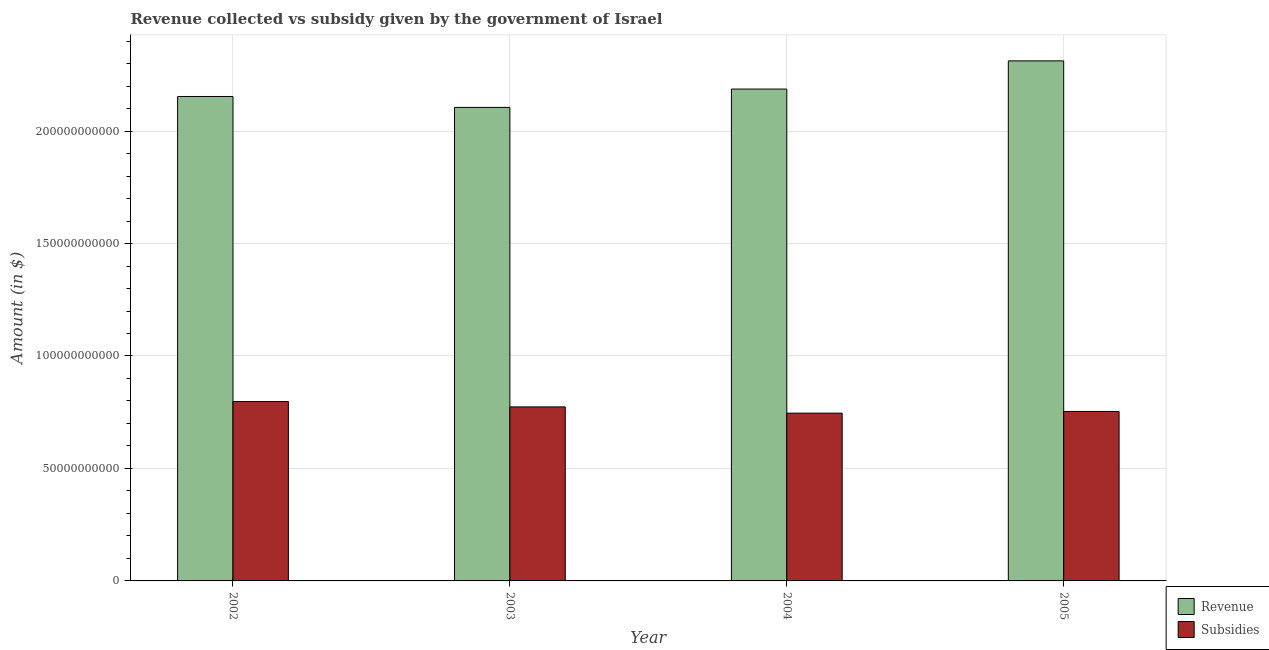How many groups of bars are there?
Offer a terse response. 4. Are the number of bars per tick equal to the number of legend labels?
Your response must be concise. Yes. How many bars are there on the 4th tick from the left?
Your answer should be compact. 2. What is the amount of subsidies given in 2003?
Keep it short and to the point. 7.74e+1. Across all years, what is the maximum amount of subsidies given?
Offer a very short reply. 7.98e+1. Across all years, what is the minimum amount of revenue collected?
Ensure brevity in your answer.  2.11e+11. In which year was the amount of revenue collected minimum?
Your response must be concise. 2003. What is the total amount of revenue collected in the graph?
Your answer should be compact. 8.76e+11. What is the difference between the amount of revenue collected in 2004 and that in 2005?
Your response must be concise. -1.25e+1. What is the difference between the amount of revenue collected in 2004 and the amount of subsidies given in 2003?
Your answer should be very brief. 8.16e+09. What is the average amount of subsidies given per year?
Make the answer very short. 7.68e+1. In the year 2003, what is the difference between the amount of subsidies given and amount of revenue collected?
Provide a succinct answer. 0. In how many years, is the amount of revenue collected greater than 60000000000 $?
Provide a succinct answer. 4. What is the ratio of the amount of subsidies given in 2003 to that in 2005?
Give a very brief answer. 1.03. Is the amount of revenue collected in 2003 less than that in 2005?
Offer a very short reply. Yes. What is the difference between the highest and the second highest amount of subsidies given?
Provide a succinct answer. 2.40e+09. What is the difference between the highest and the lowest amount of revenue collected?
Offer a very short reply. 2.07e+1. In how many years, is the amount of revenue collected greater than the average amount of revenue collected taken over all years?
Offer a very short reply. 1. What does the 2nd bar from the left in 2004 represents?
Give a very brief answer. Subsidies. What does the 2nd bar from the right in 2002 represents?
Your response must be concise. Revenue. How many bars are there?
Ensure brevity in your answer.  8. What is the difference between two consecutive major ticks on the Y-axis?
Your response must be concise. 5.00e+1. Does the graph contain grids?
Provide a short and direct response. Yes. How many legend labels are there?
Offer a very short reply. 2. What is the title of the graph?
Make the answer very short. Revenue collected vs subsidy given by the government of Israel. What is the label or title of the X-axis?
Make the answer very short. Year. What is the label or title of the Y-axis?
Your response must be concise. Amount (in $). What is the Amount (in $) of Revenue in 2002?
Provide a succinct answer. 2.15e+11. What is the Amount (in $) in Subsidies in 2002?
Make the answer very short. 7.98e+1. What is the Amount (in $) in Revenue in 2003?
Your answer should be very brief. 2.11e+11. What is the Amount (in $) in Subsidies in 2003?
Ensure brevity in your answer.  7.74e+1. What is the Amount (in $) in Revenue in 2004?
Give a very brief answer. 2.19e+11. What is the Amount (in $) in Subsidies in 2004?
Ensure brevity in your answer.  7.46e+1. What is the Amount (in $) in Revenue in 2005?
Offer a very short reply. 2.31e+11. What is the Amount (in $) of Subsidies in 2005?
Give a very brief answer. 7.53e+1. Across all years, what is the maximum Amount (in $) in Revenue?
Keep it short and to the point. 2.31e+11. Across all years, what is the maximum Amount (in $) in Subsidies?
Your response must be concise. 7.98e+1. Across all years, what is the minimum Amount (in $) of Revenue?
Make the answer very short. 2.11e+11. Across all years, what is the minimum Amount (in $) in Subsidies?
Provide a succinct answer. 7.46e+1. What is the total Amount (in $) of Revenue in the graph?
Offer a terse response. 8.76e+11. What is the total Amount (in $) of Subsidies in the graph?
Keep it short and to the point. 3.07e+11. What is the difference between the Amount (in $) in Revenue in 2002 and that in 2003?
Make the answer very short. 4.85e+09. What is the difference between the Amount (in $) in Subsidies in 2002 and that in 2003?
Offer a very short reply. 2.40e+09. What is the difference between the Amount (in $) of Revenue in 2002 and that in 2004?
Give a very brief answer. -3.30e+09. What is the difference between the Amount (in $) in Subsidies in 2002 and that in 2004?
Your answer should be compact. 5.18e+09. What is the difference between the Amount (in $) of Revenue in 2002 and that in 2005?
Ensure brevity in your answer.  -1.58e+1. What is the difference between the Amount (in $) in Subsidies in 2002 and that in 2005?
Keep it short and to the point. 4.43e+09. What is the difference between the Amount (in $) in Revenue in 2003 and that in 2004?
Make the answer very short. -8.16e+09. What is the difference between the Amount (in $) in Subsidies in 2003 and that in 2004?
Your response must be concise. 2.78e+09. What is the difference between the Amount (in $) in Revenue in 2003 and that in 2005?
Keep it short and to the point. -2.07e+1. What is the difference between the Amount (in $) in Subsidies in 2003 and that in 2005?
Give a very brief answer. 2.03e+09. What is the difference between the Amount (in $) in Revenue in 2004 and that in 2005?
Your response must be concise. -1.25e+1. What is the difference between the Amount (in $) of Subsidies in 2004 and that in 2005?
Provide a short and direct response. -7.47e+08. What is the difference between the Amount (in $) of Revenue in 2002 and the Amount (in $) of Subsidies in 2003?
Your response must be concise. 1.38e+11. What is the difference between the Amount (in $) of Revenue in 2002 and the Amount (in $) of Subsidies in 2004?
Your response must be concise. 1.41e+11. What is the difference between the Amount (in $) of Revenue in 2002 and the Amount (in $) of Subsidies in 2005?
Give a very brief answer. 1.40e+11. What is the difference between the Amount (in $) of Revenue in 2003 and the Amount (in $) of Subsidies in 2004?
Your answer should be compact. 1.36e+11. What is the difference between the Amount (in $) of Revenue in 2003 and the Amount (in $) of Subsidies in 2005?
Keep it short and to the point. 1.35e+11. What is the difference between the Amount (in $) of Revenue in 2004 and the Amount (in $) of Subsidies in 2005?
Keep it short and to the point. 1.43e+11. What is the average Amount (in $) of Revenue per year?
Offer a very short reply. 2.19e+11. What is the average Amount (in $) in Subsidies per year?
Offer a terse response. 7.68e+1. In the year 2002, what is the difference between the Amount (in $) of Revenue and Amount (in $) of Subsidies?
Provide a succinct answer. 1.36e+11. In the year 2003, what is the difference between the Amount (in $) of Revenue and Amount (in $) of Subsidies?
Ensure brevity in your answer.  1.33e+11. In the year 2004, what is the difference between the Amount (in $) of Revenue and Amount (in $) of Subsidies?
Make the answer very short. 1.44e+11. In the year 2005, what is the difference between the Amount (in $) of Revenue and Amount (in $) of Subsidies?
Offer a terse response. 1.56e+11. What is the ratio of the Amount (in $) in Revenue in 2002 to that in 2003?
Give a very brief answer. 1.02. What is the ratio of the Amount (in $) of Subsidies in 2002 to that in 2003?
Offer a terse response. 1.03. What is the ratio of the Amount (in $) in Revenue in 2002 to that in 2004?
Offer a terse response. 0.98. What is the ratio of the Amount (in $) in Subsidies in 2002 to that in 2004?
Offer a terse response. 1.07. What is the ratio of the Amount (in $) of Revenue in 2002 to that in 2005?
Your answer should be compact. 0.93. What is the ratio of the Amount (in $) of Subsidies in 2002 to that in 2005?
Make the answer very short. 1.06. What is the ratio of the Amount (in $) of Revenue in 2003 to that in 2004?
Give a very brief answer. 0.96. What is the ratio of the Amount (in $) of Subsidies in 2003 to that in 2004?
Make the answer very short. 1.04. What is the ratio of the Amount (in $) of Revenue in 2003 to that in 2005?
Keep it short and to the point. 0.91. What is the ratio of the Amount (in $) in Subsidies in 2003 to that in 2005?
Your response must be concise. 1.03. What is the ratio of the Amount (in $) in Revenue in 2004 to that in 2005?
Provide a short and direct response. 0.95. What is the ratio of the Amount (in $) of Subsidies in 2004 to that in 2005?
Your answer should be compact. 0.99. What is the difference between the highest and the second highest Amount (in $) in Revenue?
Provide a succinct answer. 1.25e+1. What is the difference between the highest and the second highest Amount (in $) of Subsidies?
Offer a terse response. 2.40e+09. What is the difference between the highest and the lowest Amount (in $) in Revenue?
Offer a terse response. 2.07e+1. What is the difference between the highest and the lowest Amount (in $) of Subsidies?
Offer a very short reply. 5.18e+09. 